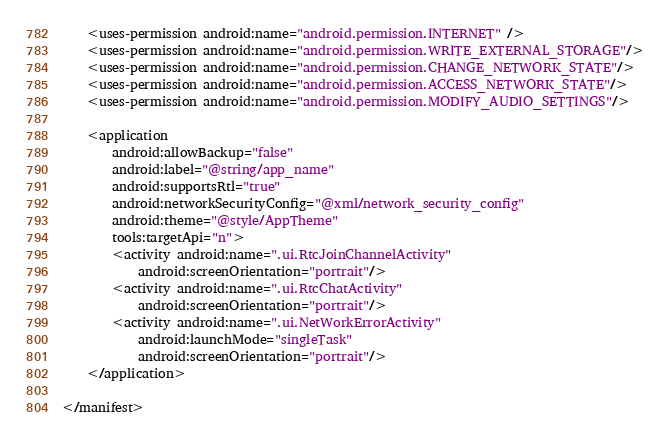Convert code to text. <code><loc_0><loc_0><loc_500><loc_500><_XML_>    <uses-permission android:name="android.permission.INTERNET" />
    <uses-permission android:name="android.permission.WRITE_EXTERNAL_STORAGE"/>
    <uses-permission android:name="android.permission.CHANGE_NETWORK_STATE"/>
    <uses-permission android:name="android.permission.ACCESS_NETWORK_STATE"/>
    <uses-permission android:name="android.permission.MODIFY_AUDIO_SETTINGS"/>

    <application
        android:allowBackup="false"
        android:label="@string/app_name"
        android:supportsRtl="true"
        android:networkSecurityConfig="@xml/network_security_config"
        android:theme="@style/AppTheme"
        tools:targetApi="n">
        <activity android:name=".ui.RtcJoinChannelActivity"
            android:screenOrientation="portrait"/>
        <activity android:name=".ui.RtcChatActivity"
            android:screenOrientation="portrait"/>
        <activity android:name=".ui.NetWorkErrorActivity"
            android:launchMode="singleTask"
            android:screenOrientation="portrait"/>
    </application>

</manifest></code> 